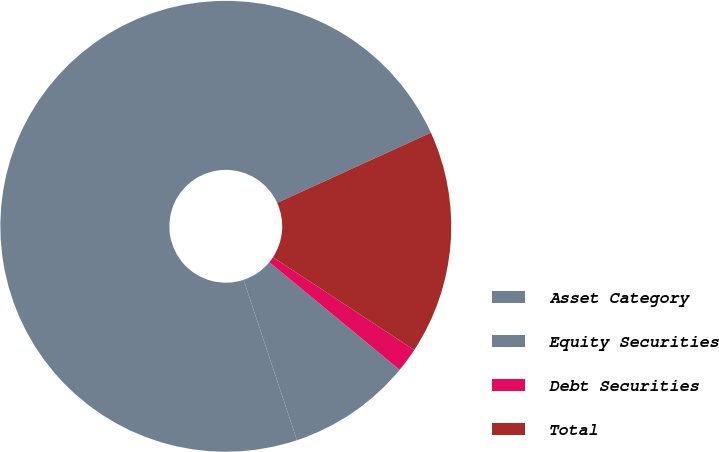Convert chart. <chart><loc_0><loc_0><loc_500><loc_500><pie_chart><fcel>Asset Category<fcel>Equity Securities<fcel>Debt Securities<fcel>Total<nl><fcel>73.3%<fcel>8.9%<fcel>1.74%<fcel>16.06%<nl></chart> 